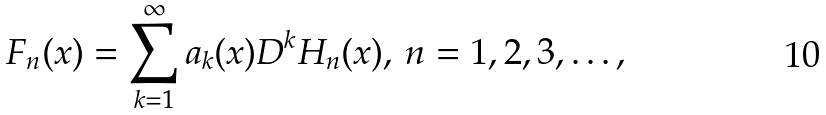Convert formula to latex. <formula><loc_0><loc_0><loc_500><loc_500>F _ { n } ( x ) = \sum _ { k = 1 } ^ { \infty } a _ { k } ( x ) D ^ { k } H _ { n } ( x ) , \, n = 1 , 2 , 3 , \dots ,</formula> 